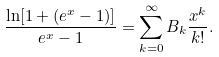<formula> <loc_0><loc_0><loc_500><loc_500>\frac { \ln [ 1 + ( e ^ { x } - 1 ) ] } { e ^ { x } - 1 } = \sum _ { k = 0 } ^ { \infty } B _ { k } \frac { x ^ { k } } { k ! } .</formula> 